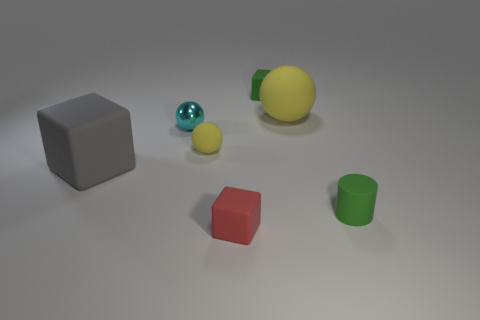Subtract all rubber balls. How many balls are left? 1 Add 2 small brown blocks. How many objects exist? 9 Subtract all gray blocks. How many blocks are left? 2 Subtract all cylinders. How many objects are left? 6 Subtract 1 cylinders. How many cylinders are left? 0 Subtract all red spheres. How many gray blocks are left? 1 Subtract all big cyan shiny balls. Subtract all cyan spheres. How many objects are left? 6 Add 2 tiny yellow matte balls. How many tiny yellow matte balls are left? 3 Add 7 big cyan cylinders. How many big cyan cylinders exist? 7 Subtract 1 red cubes. How many objects are left? 6 